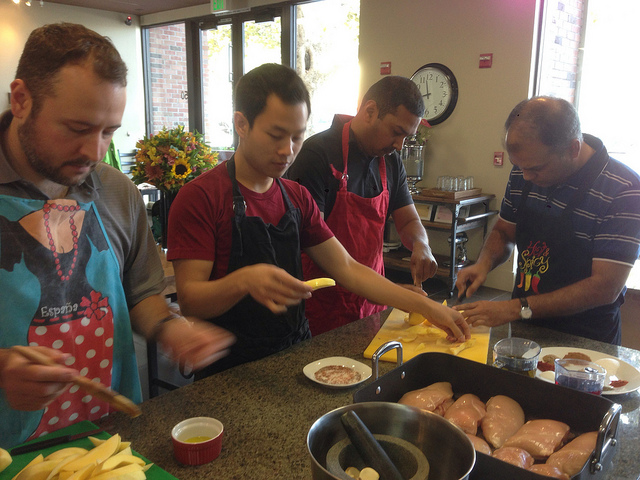How many people are there? 4 